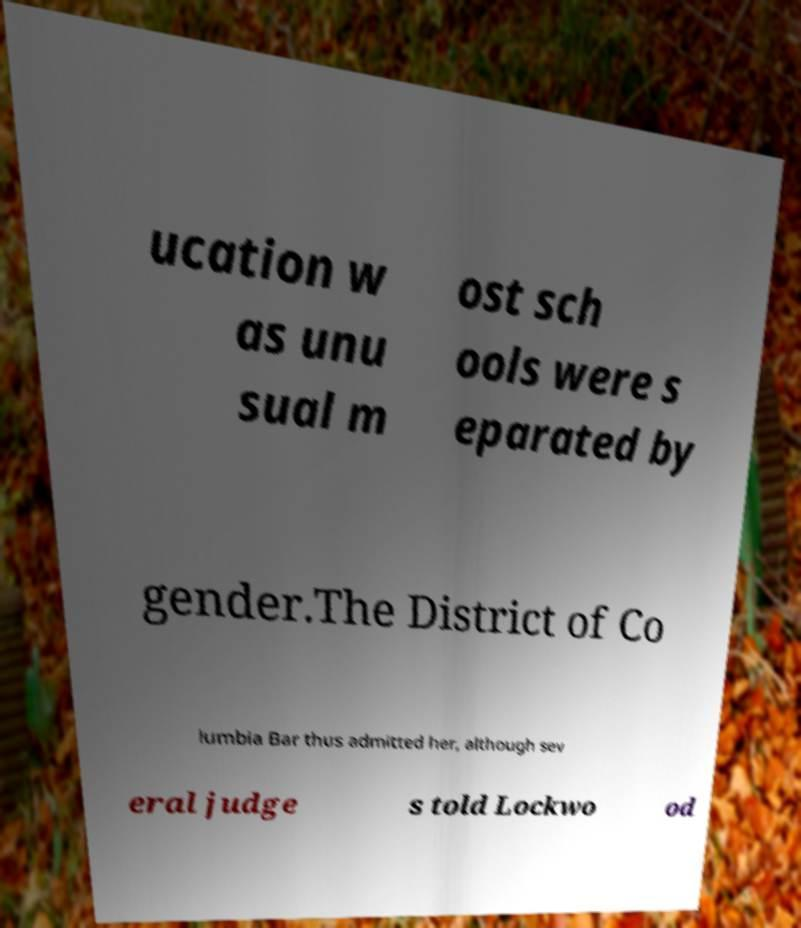Please read and relay the text visible in this image. What does it say? ucation w as unu sual m ost sch ools were s eparated by gender.The District of Co lumbia Bar thus admitted her, although sev eral judge s told Lockwo od 